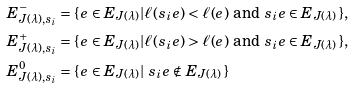<formula> <loc_0><loc_0><loc_500><loc_500>E _ { J ( \lambda ) , s _ { i } } ^ { - } & = \{ \, e \in E _ { J ( \lambda ) } | \text {$\ell(s_{i}e)<\ell(e)$ and $s_{i}e\in E_{J(\lambda)}$} \, \} , \\ E _ { J ( \lambda ) , s _ { i } } ^ { + } & = \{ \, e \in E _ { J ( \lambda ) } | \text {$\ell(s_{i}e)>\ell(e)$ and  $s_{i}e\in E_{J(\lambda)}$} \, \} , \\ E _ { J ( \lambda ) , s _ { i } } ^ { 0 } & = \{ \, e \in E _ { J ( \lambda ) } | \text { $s_{i}e\notin E_{J(\lambda)}$} \, \}</formula> 